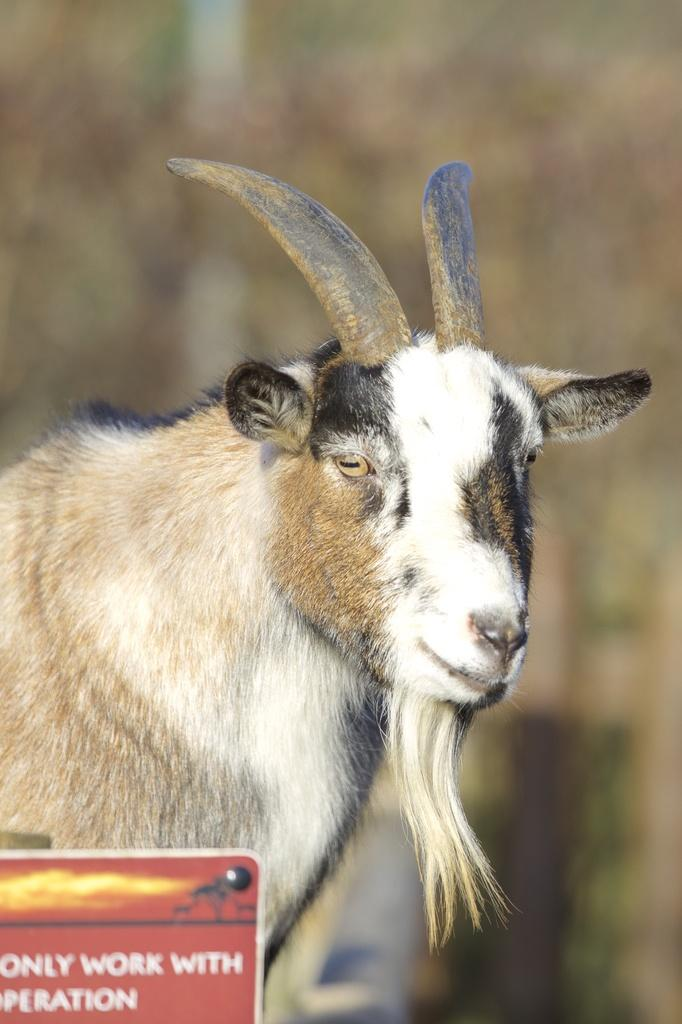What is the main subject of the image? The main subject of the image is a photograph of a goat. What are the distinguishing features of the goat? The goat has horns, and some parts of the goat are white in color, while others are black. What type of organization is being taught in the image? There is no organization or teaching present in the image; it features a photograph of a goat. What meal is being prepared in the image? There is no meal preparation or food present in the image; it features a photograph of a goat. 